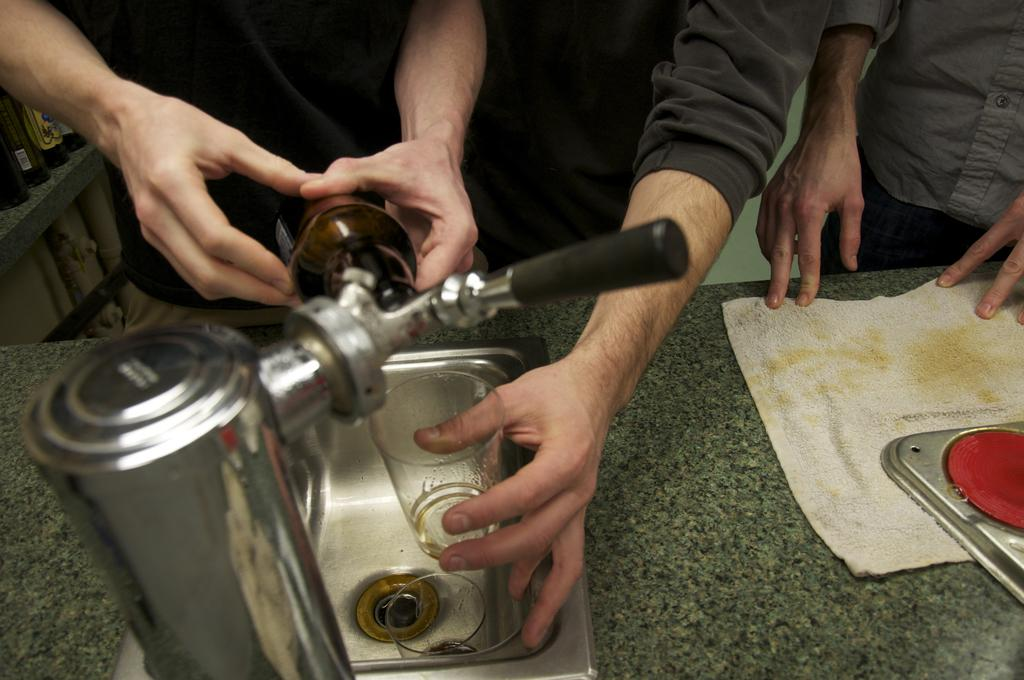What color is the napkin in the image? The napkin in the image is white. What can be found near the napkin in the image? There is a sink in the image. What is attached to the sink in the image? There is a tap on the platform in the image. What are the people in the image doing with their hands? People are holding things in their hands in the image. Can you see the ocean in the image? No, there is no ocean present in the image. Is there a crown visible on anyone's head in the image? No, there is no crown visible in the image. 